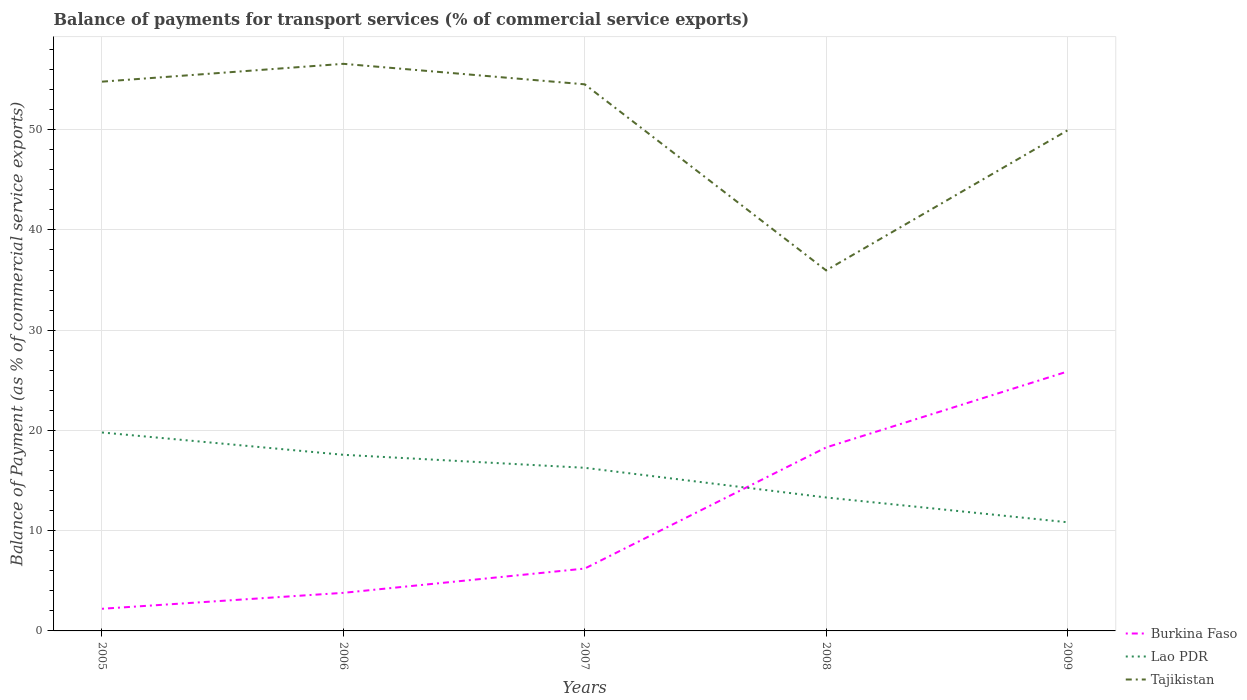Across all years, what is the maximum balance of payments for transport services in Burkina Faso?
Ensure brevity in your answer.  2.21. In which year was the balance of payments for transport services in Burkina Faso maximum?
Give a very brief answer. 2005. What is the total balance of payments for transport services in Tajikistan in the graph?
Keep it short and to the point. 0.27. What is the difference between the highest and the second highest balance of payments for transport services in Lao PDR?
Offer a very short reply. 8.96. What is the difference between the highest and the lowest balance of payments for transport services in Burkina Faso?
Your answer should be compact. 2. Is the balance of payments for transport services in Tajikistan strictly greater than the balance of payments for transport services in Lao PDR over the years?
Ensure brevity in your answer.  No. What is the difference between two consecutive major ticks on the Y-axis?
Offer a terse response. 10. Are the values on the major ticks of Y-axis written in scientific E-notation?
Your response must be concise. No. Does the graph contain grids?
Provide a succinct answer. Yes. What is the title of the graph?
Keep it short and to the point. Balance of payments for transport services (% of commercial service exports). Does "Latin America(developing only)" appear as one of the legend labels in the graph?
Your answer should be very brief. No. What is the label or title of the X-axis?
Provide a succinct answer. Years. What is the label or title of the Y-axis?
Give a very brief answer. Balance of Payment (as % of commercial service exports). What is the Balance of Payment (as % of commercial service exports) in Burkina Faso in 2005?
Provide a short and direct response. 2.21. What is the Balance of Payment (as % of commercial service exports) of Lao PDR in 2005?
Give a very brief answer. 19.8. What is the Balance of Payment (as % of commercial service exports) of Tajikistan in 2005?
Offer a terse response. 54.79. What is the Balance of Payment (as % of commercial service exports) of Burkina Faso in 2006?
Provide a short and direct response. 3.8. What is the Balance of Payment (as % of commercial service exports) in Lao PDR in 2006?
Keep it short and to the point. 17.57. What is the Balance of Payment (as % of commercial service exports) in Tajikistan in 2006?
Your response must be concise. 56.57. What is the Balance of Payment (as % of commercial service exports) of Burkina Faso in 2007?
Keep it short and to the point. 6.22. What is the Balance of Payment (as % of commercial service exports) in Lao PDR in 2007?
Give a very brief answer. 16.27. What is the Balance of Payment (as % of commercial service exports) in Tajikistan in 2007?
Keep it short and to the point. 54.53. What is the Balance of Payment (as % of commercial service exports) of Burkina Faso in 2008?
Give a very brief answer. 18.3. What is the Balance of Payment (as % of commercial service exports) of Lao PDR in 2008?
Offer a terse response. 13.31. What is the Balance of Payment (as % of commercial service exports) in Tajikistan in 2008?
Provide a succinct answer. 35.96. What is the Balance of Payment (as % of commercial service exports) of Burkina Faso in 2009?
Keep it short and to the point. 25.88. What is the Balance of Payment (as % of commercial service exports) in Lao PDR in 2009?
Make the answer very short. 10.84. What is the Balance of Payment (as % of commercial service exports) of Tajikistan in 2009?
Provide a short and direct response. 49.93. Across all years, what is the maximum Balance of Payment (as % of commercial service exports) of Burkina Faso?
Provide a short and direct response. 25.88. Across all years, what is the maximum Balance of Payment (as % of commercial service exports) of Lao PDR?
Make the answer very short. 19.8. Across all years, what is the maximum Balance of Payment (as % of commercial service exports) in Tajikistan?
Give a very brief answer. 56.57. Across all years, what is the minimum Balance of Payment (as % of commercial service exports) in Burkina Faso?
Provide a succinct answer. 2.21. Across all years, what is the minimum Balance of Payment (as % of commercial service exports) in Lao PDR?
Your answer should be compact. 10.84. Across all years, what is the minimum Balance of Payment (as % of commercial service exports) in Tajikistan?
Keep it short and to the point. 35.96. What is the total Balance of Payment (as % of commercial service exports) of Burkina Faso in the graph?
Offer a very short reply. 56.41. What is the total Balance of Payment (as % of commercial service exports) of Lao PDR in the graph?
Your response must be concise. 77.79. What is the total Balance of Payment (as % of commercial service exports) in Tajikistan in the graph?
Keep it short and to the point. 251.79. What is the difference between the Balance of Payment (as % of commercial service exports) of Burkina Faso in 2005 and that in 2006?
Provide a short and direct response. -1.59. What is the difference between the Balance of Payment (as % of commercial service exports) in Lao PDR in 2005 and that in 2006?
Offer a very short reply. 2.23. What is the difference between the Balance of Payment (as % of commercial service exports) of Tajikistan in 2005 and that in 2006?
Ensure brevity in your answer.  -1.78. What is the difference between the Balance of Payment (as % of commercial service exports) of Burkina Faso in 2005 and that in 2007?
Provide a short and direct response. -4.01. What is the difference between the Balance of Payment (as % of commercial service exports) in Lao PDR in 2005 and that in 2007?
Provide a short and direct response. 3.52. What is the difference between the Balance of Payment (as % of commercial service exports) in Tajikistan in 2005 and that in 2007?
Keep it short and to the point. 0.27. What is the difference between the Balance of Payment (as % of commercial service exports) in Burkina Faso in 2005 and that in 2008?
Provide a succinct answer. -16.09. What is the difference between the Balance of Payment (as % of commercial service exports) of Lao PDR in 2005 and that in 2008?
Your answer should be very brief. 6.48. What is the difference between the Balance of Payment (as % of commercial service exports) of Tajikistan in 2005 and that in 2008?
Give a very brief answer. 18.83. What is the difference between the Balance of Payment (as % of commercial service exports) of Burkina Faso in 2005 and that in 2009?
Your answer should be very brief. -23.67. What is the difference between the Balance of Payment (as % of commercial service exports) in Lao PDR in 2005 and that in 2009?
Ensure brevity in your answer.  8.96. What is the difference between the Balance of Payment (as % of commercial service exports) of Tajikistan in 2005 and that in 2009?
Your response must be concise. 4.86. What is the difference between the Balance of Payment (as % of commercial service exports) in Burkina Faso in 2006 and that in 2007?
Give a very brief answer. -2.42. What is the difference between the Balance of Payment (as % of commercial service exports) of Lao PDR in 2006 and that in 2007?
Keep it short and to the point. 1.3. What is the difference between the Balance of Payment (as % of commercial service exports) of Tajikistan in 2006 and that in 2007?
Your answer should be very brief. 2.05. What is the difference between the Balance of Payment (as % of commercial service exports) of Burkina Faso in 2006 and that in 2008?
Your response must be concise. -14.5. What is the difference between the Balance of Payment (as % of commercial service exports) in Lao PDR in 2006 and that in 2008?
Keep it short and to the point. 4.26. What is the difference between the Balance of Payment (as % of commercial service exports) in Tajikistan in 2006 and that in 2008?
Ensure brevity in your answer.  20.61. What is the difference between the Balance of Payment (as % of commercial service exports) in Burkina Faso in 2006 and that in 2009?
Make the answer very short. -22.08. What is the difference between the Balance of Payment (as % of commercial service exports) in Lao PDR in 2006 and that in 2009?
Offer a terse response. 6.73. What is the difference between the Balance of Payment (as % of commercial service exports) in Tajikistan in 2006 and that in 2009?
Offer a very short reply. 6.64. What is the difference between the Balance of Payment (as % of commercial service exports) of Burkina Faso in 2007 and that in 2008?
Your answer should be compact. -12.08. What is the difference between the Balance of Payment (as % of commercial service exports) of Lao PDR in 2007 and that in 2008?
Ensure brevity in your answer.  2.96. What is the difference between the Balance of Payment (as % of commercial service exports) in Tajikistan in 2007 and that in 2008?
Provide a short and direct response. 18.56. What is the difference between the Balance of Payment (as % of commercial service exports) of Burkina Faso in 2007 and that in 2009?
Make the answer very short. -19.66. What is the difference between the Balance of Payment (as % of commercial service exports) of Lao PDR in 2007 and that in 2009?
Provide a short and direct response. 5.43. What is the difference between the Balance of Payment (as % of commercial service exports) of Tajikistan in 2007 and that in 2009?
Give a very brief answer. 4.59. What is the difference between the Balance of Payment (as % of commercial service exports) of Burkina Faso in 2008 and that in 2009?
Your response must be concise. -7.58. What is the difference between the Balance of Payment (as % of commercial service exports) in Lao PDR in 2008 and that in 2009?
Your answer should be very brief. 2.47. What is the difference between the Balance of Payment (as % of commercial service exports) of Tajikistan in 2008 and that in 2009?
Your answer should be compact. -13.97. What is the difference between the Balance of Payment (as % of commercial service exports) in Burkina Faso in 2005 and the Balance of Payment (as % of commercial service exports) in Lao PDR in 2006?
Offer a terse response. -15.36. What is the difference between the Balance of Payment (as % of commercial service exports) in Burkina Faso in 2005 and the Balance of Payment (as % of commercial service exports) in Tajikistan in 2006?
Provide a succinct answer. -54.36. What is the difference between the Balance of Payment (as % of commercial service exports) of Lao PDR in 2005 and the Balance of Payment (as % of commercial service exports) of Tajikistan in 2006?
Make the answer very short. -36.78. What is the difference between the Balance of Payment (as % of commercial service exports) in Burkina Faso in 2005 and the Balance of Payment (as % of commercial service exports) in Lao PDR in 2007?
Offer a very short reply. -14.06. What is the difference between the Balance of Payment (as % of commercial service exports) in Burkina Faso in 2005 and the Balance of Payment (as % of commercial service exports) in Tajikistan in 2007?
Keep it short and to the point. -52.32. What is the difference between the Balance of Payment (as % of commercial service exports) in Lao PDR in 2005 and the Balance of Payment (as % of commercial service exports) in Tajikistan in 2007?
Ensure brevity in your answer.  -34.73. What is the difference between the Balance of Payment (as % of commercial service exports) in Burkina Faso in 2005 and the Balance of Payment (as % of commercial service exports) in Lao PDR in 2008?
Give a very brief answer. -11.1. What is the difference between the Balance of Payment (as % of commercial service exports) in Burkina Faso in 2005 and the Balance of Payment (as % of commercial service exports) in Tajikistan in 2008?
Give a very brief answer. -33.76. What is the difference between the Balance of Payment (as % of commercial service exports) in Lao PDR in 2005 and the Balance of Payment (as % of commercial service exports) in Tajikistan in 2008?
Your answer should be compact. -16.17. What is the difference between the Balance of Payment (as % of commercial service exports) of Burkina Faso in 2005 and the Balance of Payment (as % of commercial service exports) of Lao PDR in 2009?
Make the answer very short. -8.63. What is the difference between the Balance of Payment (as % of commercial service exports) in Burkina Faso in 2005 and the Balance of Payment (as % of commercial service exports) in Tajikistan in 2009?
Your response must be concise. -47.72. What is the difference between the Balance of Payment (as % of commercial service exports) in Lao PDR in 2005 and the Balance of Payment (as % of commercial service exports) in Tajikistan in 2009?
Your response must be concise. -30.14. What is the difference between the Balance of Payment (as % of commercial service exports) of Burkina Faso in 2006 and the Balance of Payment (as % of commercial service exports) of Lao PDR in 2007?
Provide a succinct answer. -12.47. What is the difference between the Balance of Payment (as % of commercial service exports) in Burkina Faso in 2006 and the Balance of Payment (as % of commercial service exports) in Tajikistan in 2007?
Your response must be concise. -50.73. What is the difference between the Balance of Payment (as % of commercial service exports) of Lao PDR in 2006 and the Balance of Payment (as % of commercial service exports) of Tajikistan in 2007?
Make the answer very short. -36.96. What is the difference between the Balance of Payment (as % of commercial service exports) of Burkina Faso in 2006 and the Balance of Payment (as % of commercial service exports) of Lao PDR in 2008?
Your answer should be very brief. -9.51. What is the difference between the Balance of Payment (as % of commercial service exports) of Burkina Faso in 2006 and the Balance of Payment (as % of commercial service exports) of Tajikistan in 2008?
Provide a short and direct response. -32.17. What is the difference between the Balance of Payment (as % of commercial service exports) of Lao PDR in 2006 and the Balance of Payment (as % of commercial service exports) of Tajikistan in 2008?
Provide a succinct answer. -18.4. What is the difference between the Balance of Payment (as % of commercial service exports) in Burkina Faso in 2006 and the Balance of Payment (as % of commercial service exports) in Lao PDR in 2009?
Offer a very short reply. -7.04. What is the difference between the Balance of Payment (as % of commercial service exports) in Burkina Faso in 2006 and the Balance of Payment (as % of commercial service exports) in Tajikistan in 2009?
Provide a short and direct response. -46.13. What is the difference between the Balance of Payment (as % of commercial service exports) in Lao PDR in 2006 and the Balance of Payment (as % of commercial service exports) in Tajikistan in 2009?
Your answer should be very brief. -32.36. What is the difference between the Balance of Payment (as % of commercial service exports) in Burkina Faso in 2007 and the Balance of Payment (as % of commercial service exports) in Lao PDR in 2008?
Your answer should be compact. -7.09. What is the difference between the Balance of Payment (as % of commercial service exports) of Burkina Faso in 2007 and the Balance of Payment (as % of commercial service exports) of Tajikistan in 2008?
Your answer should be compact. -29.74. What is the difference between the Balance of Payment (as % of commercial service exports) in Lao PDR in 2007 and the Balance of Payment (as % of commercial service exports) in Tajikistan in 2008?
Make the answer very short. -19.69. What is the difference between the Balance of Payment (as % of commercial service exports) of Burkina Faso in 2007 and the Balance of Payment (as % of commercial service exports) of Lao PDR in 2009?
Your response must be concise. -4.62. What is the difference between the Balance of Payment (as % of commercial service exports) of Burkina Faso in 2007 and the Balance of Payment (as % of commercial service exports) of Tajikistan in 2009?
Offer a terse response. -43.71. What is the difference between the Balance of Payment (as % of commercial service exports) in Lao PDR in 2007 and the Balance of Payment (as % of commercial service exports) in Tajikistan in 2009?
Your answer should be compact. -33.66. What is the difference between the Balance of Payment (as % of commercial service exports) of Burkina Faso in 2008 and the Balance of Payment (as % of commercial service exports) of Lao PDR in 2009?
Provide a succinct answer. 7.46. What is the difference between the Balance of Payment (as % of commercial service exports) of Burkina Faso in 2008 and the Balance of Payment (as % of commercial service exports) of Tajikistan in 2009?
Keep it short and to the point. -31.63. What is the difference between the Balance of Payment (as % of commercial service exports) in Lao PDR in 2008 and the Balance of Payment (as % of commercial service exports) in Tajikistan in 2009?
Provide a short and direct response. -36.62. What is the average Balance of Payment (as % of commercial service exports) of Burkina Faso per year?
Your answer should be very brief. 11.28. What is the average Balance of Payment (as % of commercial service exports) in Lao PDR per year?
Ensure brevity in your answer.  15.56. What is the average Balance of Payment (as % of commercial service exports) of Tajikistan per year?
Your answer should be very brief. 50.36. In the year 2005, what is the difference between the Balance of Payment (as % of commercial service exports) of Burkina Faso and Balance of Payment (as % of commercial service exports) of Lao PDR?
Your response must be concise. -17.59. In the year 2005, what is the difference between the Balance of Payment (as % of commercial service exports) in Burkina Faso and Balance of Payment (as % of commercial service exports) in Tajikistan?
Your answer should be compact. -52.58. In the year 2005, what is the difference between the Balance of Payment (as % of commercial service exports) of Lao PDR and Balance of Payment (as % of commercial service exports) of Tajikistan?
Provide a succinct answer. -35. In the year 2006, what is the difference between the Balance of Payment (as % of commercial service exports) in Burkina Faso and Balance of Payment (as % of commercial service exports) in Lao PDR?
Offer a very short reply. -13.77. In the year 2006, what is the difference between the Balance of Payment (as % of commercial service exports) in Burkina Faso and Balance of Payment (as % of commercial service exports) in Tajikistan?
Keep it short and to the point. -52.77. In the year 2006, what is the difference between the Balance of Payment (as % of commercial service exports) in Lao PDR and Balance of Payment (as % of commercial service exports) in Tajikistan?
Provide a succinct answer. -39. In the year 2007, what is the difference between the Balance of Payment (as % of commercial service exports) in Burkina Faso and Balance of Payment (as % of commercial service exports) in Lao PDR?
Provide a short and direct response. -10.05. In the year 2007, what is the difference between the Balance of Payment (as % of commercial service exports) of Burkina Faso and Balance of Payment (as % of commercial service exports) of Tajikistan?
Provide a succinct answer. -48.31. In the year 2007, what is the difference between the Balance of Payment (as % of commercial service exports) of Lao PDR and Balance of Payment (as % of commercial service exports) of Tajikistan?
Ensure brevity in your answer.  -38.25. In the year 2008, what is the difference between the Balance of Payment (as % of commercial service exports) of Burkina Faso and Balance of Payment (as % of commercial service exports) of Lao PDR?
Offer a terse response. 4.99. In the year 2008, what is the difference between the Balance of Payment (as % of commercial service exports) in Burkina Faso and Balance of Payment (as % of commercial service exports) in Tajikistan?
Ensure brevity in your answer.  -17.66. In the year 2008, what is the difference between the Balance of Payment (as % of commercial service exports) of Lao PDR and Balance of Payment (as % of commercial service exports) of Tajikistan?
Make the answer very short. -22.65. In the year 2009, what is the difference between the Balance of Payment (as % of commercial service exports) of Burkina Faso and Balance of Payment (as % of commercial service exports) of Lao PDR?
Offer a very short reply. 15.04. In the year 2009, what is the difference between the Balance of Payment (as % of commercial service exports) in Burkina Faso and Balance of Payment (as % of commercial service exports) in Tajikistan?
Your answer should be compact. -24.05. In the year 2009, what is the difference between the Balance of Payment (as % of commercial service exports) in Lao PDR and Balance of Payment (as % of commercial service exports) in Tajikistan?
Provide a succinct answer. -39.09. What is the ratio of the Balance of Payment (as % of commercial service exports) in Burkina Faso in 2005 to that in 2006?
Keep it short and to the point. 0.58. What is the ratio of the Balance of Payment (as % of commercial service exports) in Lao PDR in 2005 to that in 2006?
Ensure brevity in your answer.  1.13. What is the ratio of the Balance of Payment (as % of commercial service exports) of Tajikistan in 2005 to that in 2006?
Keep it short and to the point. 0.97. What is the ratio of the Balance of Payment (as % of commercial service exports) of Burkina Faso in 2005 to that in 2007?
Your answer should be very brief. 0.36. What is the ratio of the Balance of Payment (as % of commercial service exports) of Lao PDR in 2005 to that in 2007?
Provide a succinct answer. 1.22. What is the ratio of the Balance of Payment (as % of commercial service exports) in Burkina Faso in 2005 to that in 2008?
Your answer should be compact. 0.12. What is the ratio of the Balance of Payment (as % of commercial service exports) in Lao PDR in 2005 to that in 2008?
Give a very brief answer. 1.49. What is the ratio of the Balance of Payment (as % of commercial service exports) of Tajikistan in 2005 to that in 2008?
Make the answer very short. 1.52. What is the ratio of the Balance of Payment (as % of commercial service exports) in Burkina Faso in 2005 to that in 2009?
Give a very brief answer. 0.09. What is the ratio of the Balance of Payment (as % of commercial service exports) in Lao PDR in 2005 to that in 2009?
Offer a terse response. 1.83. What is the ratio of the Balance of Payment (as % of commercial service exports) of Tajikistan in 2005 to that in 2009?
Your response must be concise. 1.1. What is the ratio of the Balance of Payment (as % of commercial service exports) of Burkina Faso in 2006 to that in 2007?
Give a very brief answer. 0.61. What is the ratio of the Balance of Payment (as % of commercial service exports) in Lao PDR in 2006 to that in 2007?
Keep it short and to the point. 1.08. What is the ratio of the Balance of Payment (as % of commercial service exports) of Tajikistan in 2006 to that in 2007?
Provide a short and direct response. 1.04. What is the ratio of the Balance of Payment (as % of commercial service exports) in Burkina Faso in 2006 to that in 2008?
Give a very brief answer. 0.21. What is the ratio of the Balance of Payment (as % of commercial service exports) of Lao PDR in 2006 to that in 2008?
Ensure brevity in your answer.  1.32. What is the ratio of the Balance of Payment (as % of commercial service exports) of Tajikistan in 2006 to that in 2008?
Offer a very short reply. 1.57. What is the ratio of the Balance of Payment (as % of commercial service exports) in Burkina Faso in 2006 to that in 2009?
Keep it short and to the point. 0.15. What is the ratio of the Balance of Payment (as % of commercial service exports) of Lao PDR in 2006 to that in 2009?
Provide a succinct answer. 1.62. What is the ratio of the Balance of Payment (as % of commercial service exports) of Tajikistan in 2006 to that in 2009?
Your response must be concise. 1.13. What is the ratio of the Balance of Payment (as % of commercial service exports) in Burkina Faso in 2007 to that in 2008?
Make the answer very short. 0.34. What is the ratio of the Balance of Payment (as % of commercial service exports) of Lao PDR in 2007 to that in 2008?
Offer a very short reply. 1.22. What is the ratio of the Balance of Payment (as % of commercial service exports) in Tajikistan in 2007 to that in 2008?
Offer a terse response. 1.52. What is the ratio of the Balance of Payment (as % of commercial service exports) of Burkina Faso in 2007 to that in 2009?
Give a very brief answer. 0.24. What is the ratio of the Balance of Payment (as % of commercial service exports) of Lao PDR in 2007 to that in 2009?
Offer a very short reply. 1.5. What is the ratio of the Balance of Payment (as % of commercial service exports) in Tajikistan in 2007 to that in 2009?
Keep it short and to the point. 1.09. What is the ratio of the Balance of Payment (as % of commercial service exports) in Burkina Faso in 2008 to that in 2009?
Ensure brevity in your answer.  0.71. What is the ratio of the Balance of Payment (as % of commercial service exports) in Lao PDR in 2008 to that in 2009?
Your answer should be very brief. 1.23. What is the ratio of the Balance of Payment (as % of commercial service exports) in Tajikistan in 2008 to that in 2009?
Ensure brevity in your answer.  0.72. What is the difference between the highest and the second highest Balance of Payment (as % of commercial service exports) in Burkina Faso?
Offer a terse response. 7.58. What is the difference between the highest and the second highest Balance of Payment (as % of commercial service exports) in Lao PDR?
Ensure brevity in your answer.  2.23. What is the difference between the highest and the second highest Balance of Payment (as % of commercial service exports) of Tajikistan?
Your answer should be compact. 1.78. What is the difference between the highest and the lowest Balance of Payment (as % of commercial service exports) of Burkina Faso?
Your answer should be compact. 23.67. What is the difference between the highest and the lowest Balance of Payment (as % of commercial service exports) of Lao PDR?
Provide a short and direct response. 8.96. What is the difference between the highest and the lowest Balance of Payment (as % of commercial service exports) in Tajikistan?
Keep it short and to the point. 20.61. 